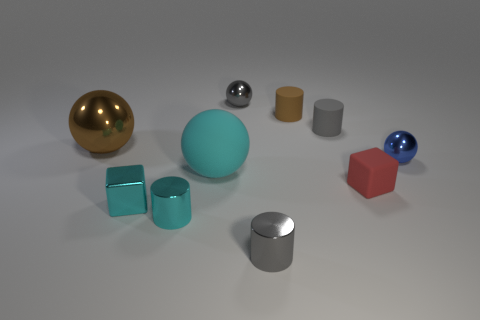What shapes are present in the image? The image contains a variety of shapes: there are spheres, cylinders, and cubes. Which shape is the most prevalent? Cubes are the most prevalent shape, appearing in both cyan and red. 